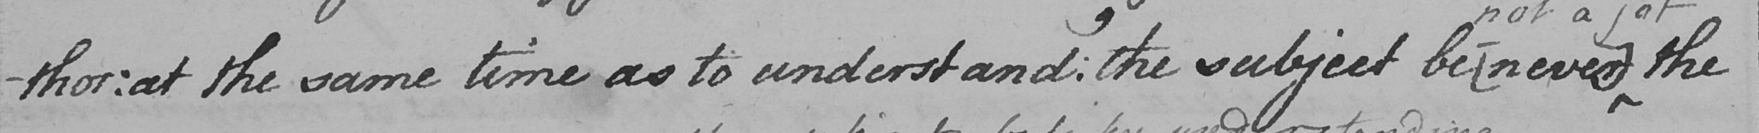What text is written in this handwritten line? -thor :  at the same time as to understand :  the subject be  [ never ]  the 